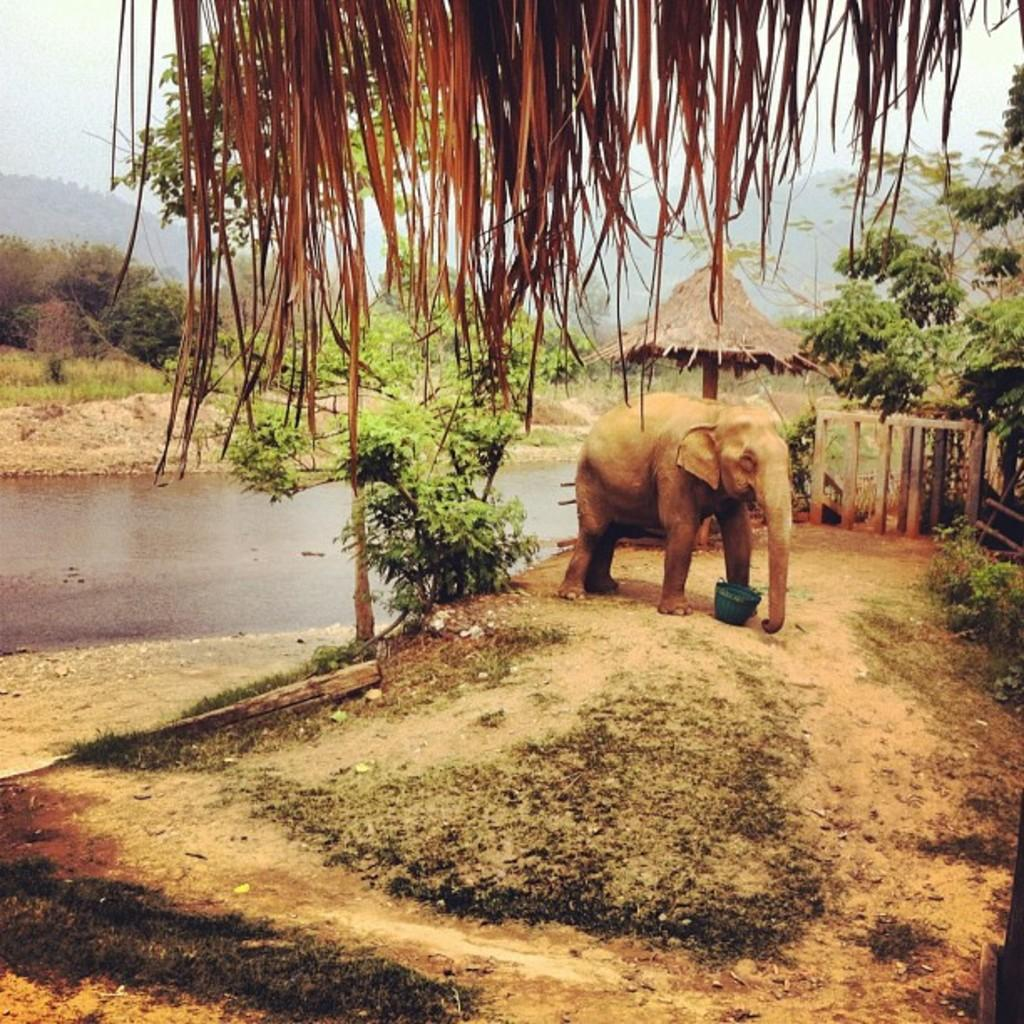What animal can be seen in the image? There is an elephant in the image. What object is present in the image that could be used for holding or carrying items? There is a bucket in the image. What type of vegetation is visible in the image? Grass, plants, and trees are present in the image. What natural feature can be seen in the image? There is a hill in the image. What part of the environment is visible in the image? The sky is visible in the image. How many yaks are present in the image? There are no yaks present in the image. What type of industry can be seen in the image? There is no industry present in the image; it features an elephant, a bucket, grass, plants, trees, water, a hill, and the sky. 